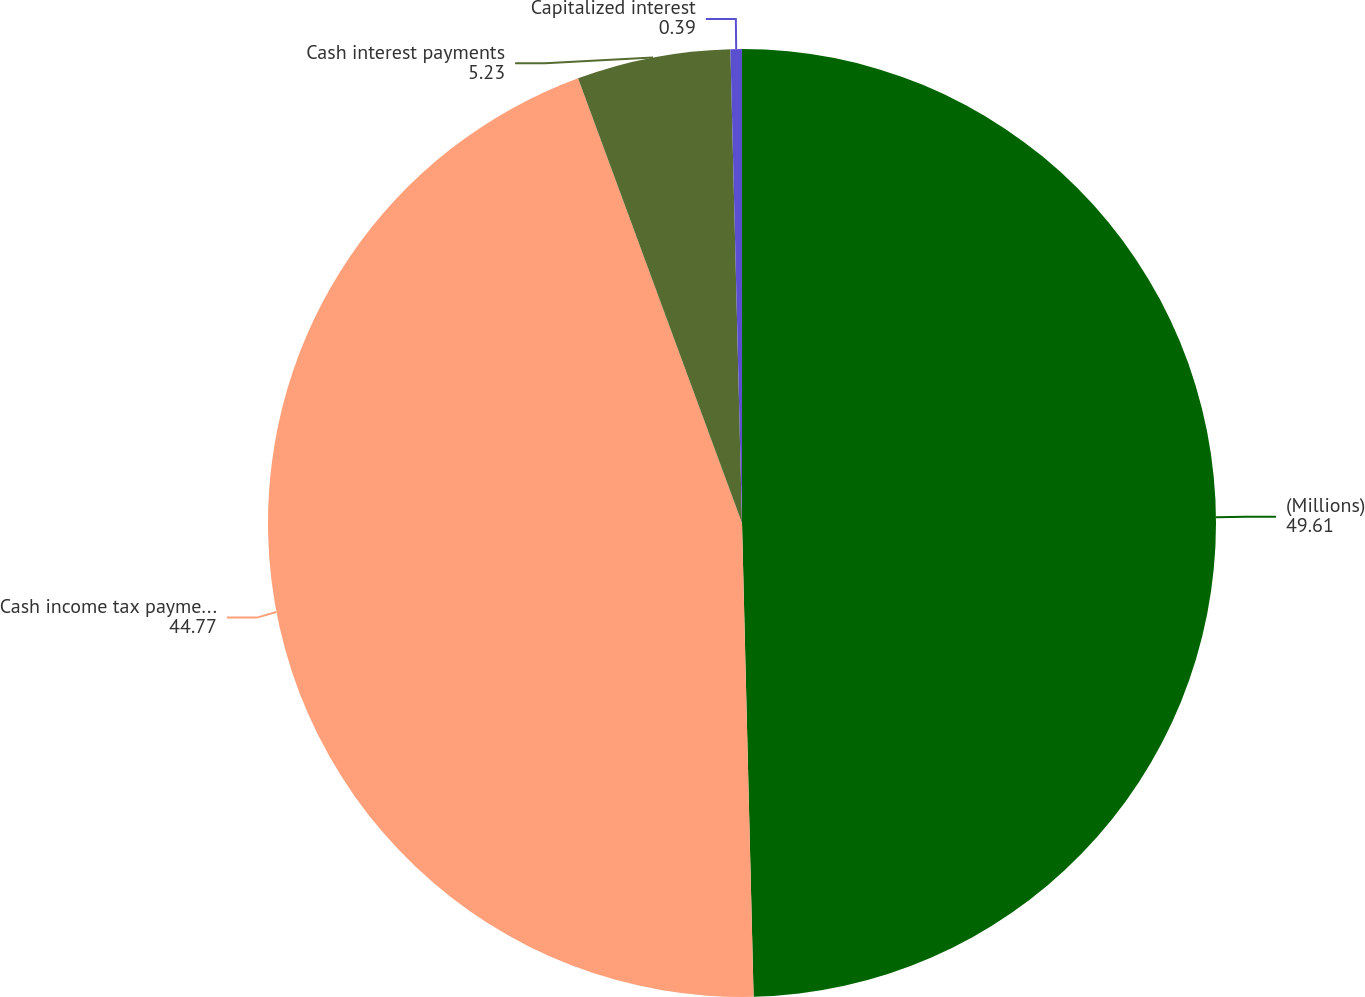Convert chart to OTSL. <chart><loc_0><loc_0><loc_500><loc_500><pie_chart><fcel>(Millions)<fcel>Cash income tax payments<fcel>Cash interest payments<fcel>Capitalized interest<nl><fcel>49.61%<fcel>44.77%<fcel>5.23%<fcel>0.39%<nl></chart> 